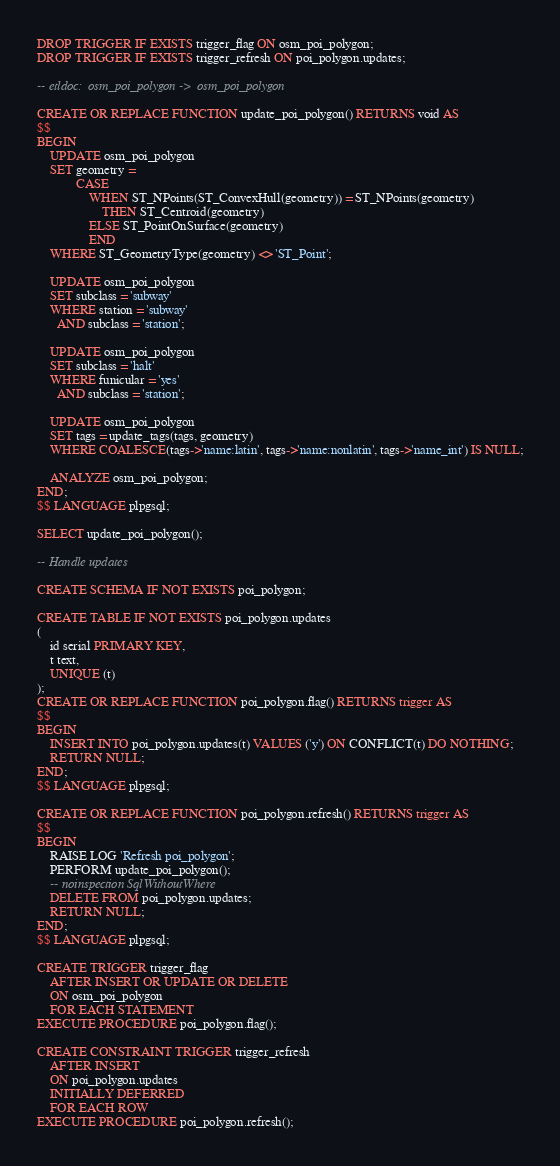<code> <loc_0><loc_0><loc_500><loc_500><_SQL_>DROP TRIGGER IF EXISTS trigger_flag ON osm_poi_polygon;
DROP TRIGGER IF EXISTS trigger_refresh ON poi_polygon.updates;

-- etldoc:  osm_poi_polygon ->  osm_poi_polygon

CREATE OR REPLACE FUNCTION update_poi_polygon() RETURNS void AS
$$
BEGIN
    UPDATE osm_poi_polygon
    SET geometry =
            CASE
                WHEN ST_NPoints(ST_ConvexHull(geometry)) = ST_NPoints(geometry)
                    THEN ST_Centroid(geometry)
                ELSE ST_PointOnSurface(geometry)
                END
    WHERE ST_GeometryType(geometry) <> 'ST_Point';

    UPDATE osm_poi_polygon
    SET subclass = 'subway'
    WHERE station = 'subway'
      AND subclass = 'station';

    UPDATE osm_poi_polygon
    SET subclass = 'halt'
    WHERE funicular = 'yes'
      AND subclass = 'station';

    UPDATE osm_poi_polygon
    SET tags = update_tags(tags, geometry)
    WHERE COALESCE(tags->'name:latin', tags->'name:nonlatin', tags->'name_int') IS NULL;

    ANALYZE osm_poi_polygon;
END;
$$ LANGUAGE plpgsql;

SELECT update_poi_polygon();

-- Handle updates

CREATE SCHEMA IF NOT EXISTS poi_polygon;

CREATE TABLE IF NOT EXISTS poi_polygon.updates
(
    id serial PRIMARY KEY,
    t text,
    UNIQUE (t)
);
CREATE OR REPLACE FUNCTION poi_polygon.flag() RETURNS trigger AS
$$
BEGIN
    INSERT INTO poi_polygon.updates(t) VALUES ('y') ON CONFLICT(t) DO NOTHING;
    RETURN NULL;
END;
$$ LANGUAGE plpgsql;

CREATE OR REPLACE FUNCTION poi_polygon.refresh() RETURNS trigger AS
$$
BEGIN
    RAISE LOG 'Refresh poi_polygon';
    PERFORM update_poi_polygon();
    -- noinspection SqlWithoutWhere
    DELETE FROM poi_polygon.updates;
    RETURN NULL;
END;
$$ LANGUAGE plpgsql;

CREATE TRIGGER trigger_flag
    AFTER INSERT OR UPDATE OR DELETE
    ON osm_poi_polygon
    FOR EACH STATEMENT
EXECUTE PROCEDURE poi_polygon.flag();

CREATE CONSTRAINT TRIGGER trigger_refresh
    AFTER INSERT
    ON poi_polygon.updates
    INITIALLY DEFERRED
    FOR EACH ROW
EXECUTE PROCEDURE poi_polygon.refresh();
</code> 